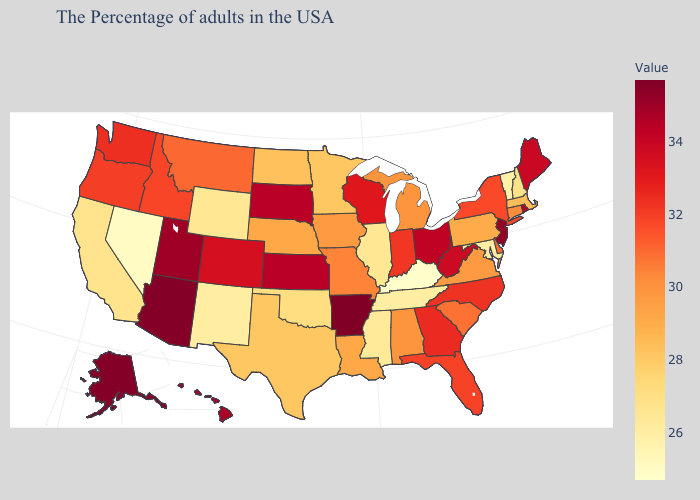Which states have the lowest value in the MidWest?
Write a very short answer. Illinois. Does Montana have a higher value than Ohio?
Short answer required. No. Which states hav the highest value in the Northeast?
Keep it brief. New Jersey. Does Vermont have the highest value in the USA?
Give a very brief answer. No. Does Vermont have the lowest value in the Northeast?
Quick response, please. Yes. Does Kentucky have the lowest value in the South?
Short answer required. Yes. Does Arkansas have the highest value in the USA?
Give a very brief answer. Yes. Does Kentucky have the lowest value in the USA?
Quick response, please. Yes. Among the states that border South Dakota , does Montana have the highest value?
Keep it brief. Yes. 